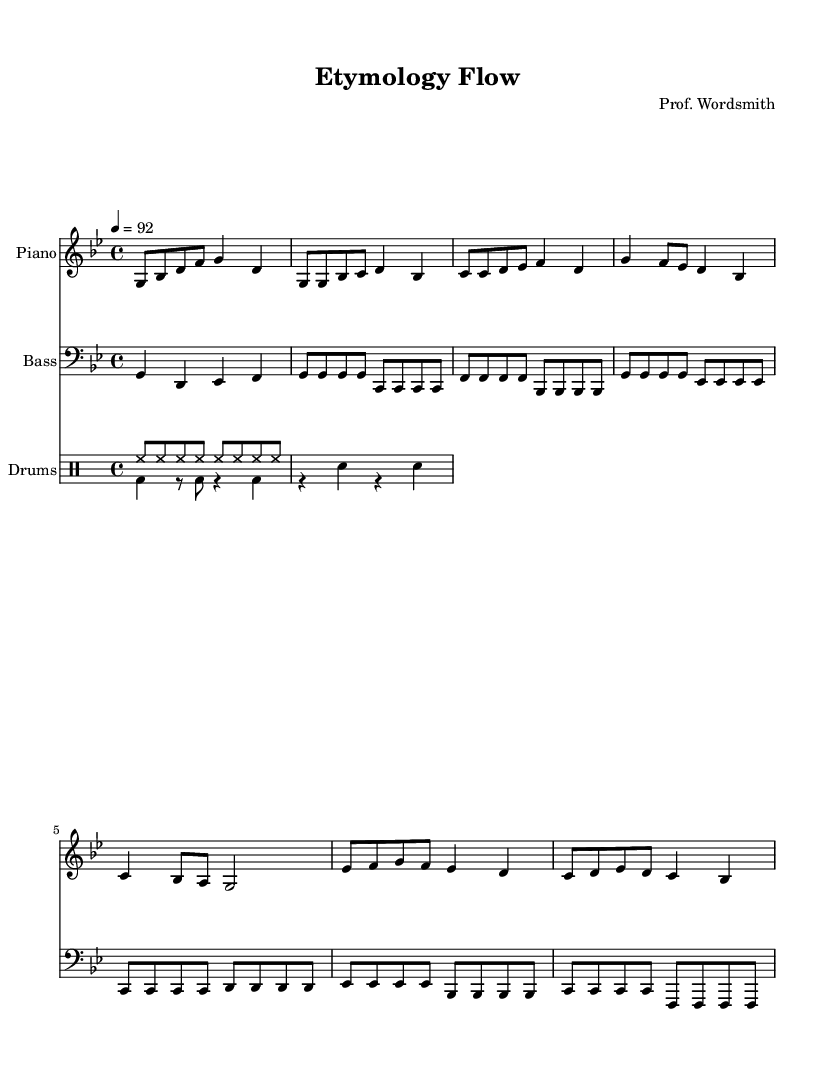What is the key signature of this music? The key signature is G minor, which includes two flats in its signature (B♭ and E♭). This can be identified from the music sheet notation that is located at the beginning of the staff lines.
Answer: G minor What is the time signature of this music? The time signature is 4/4, meaning there are four beats in each measure and the quarter note receives one beat. This information is indicated at the beginning of the piece with the symbols appearing after the key signature.
Answer: 4/4 What is the tempo marking of this piece? The tempo marking is 92 beats per minute, as indicated by the "4 = 92" notation at the beginning of the score, where the number specifies the beats per minute for the quarter note.
Answer: 92 What type of drums are predominantly used in this score? The drums section includes a hi-hat and bass drum, which can be inferred by looking at the specific notations for rhythm patterns in the drum part. The hi-hat is frequently notated, showing its central role in the music.
Answer: Hi-hat and bass drum How many measures are there in the piano section? There are a total of 8 measures in the piano section, which can be determined by counting the distinct sets of vertical lines that separate the measures in the notation. Each segment or space between these lines represents a measure.
Answer: 8 What rhythmic pattern is used for the hi-hat? The hi-hat is played in continuous eighth notes, as shown in the drumming notation where the hi-hat is marked consistently throughout each measure in sequence. This indicates a steady rhythm, typical in hip-hop music.
Answer: Eighth notes Identify the presence of a bass line in the music. The bass line is present and can be identified by the separate bass staff under the piano part, which features notated lines that indicate lower frequencies crucial for the harmonic aspect of the composition.
Answer: Yes 